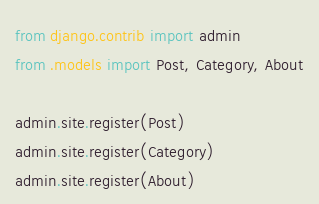Convert code to text. <code><loc_0><loc_0><loc_500><loc_500><_Python_>from django.contrib import admin
from .models import Post, Category, About

admin.site.register(Post)
admin.site.register(Category)
admin.site.register(About)</code> 